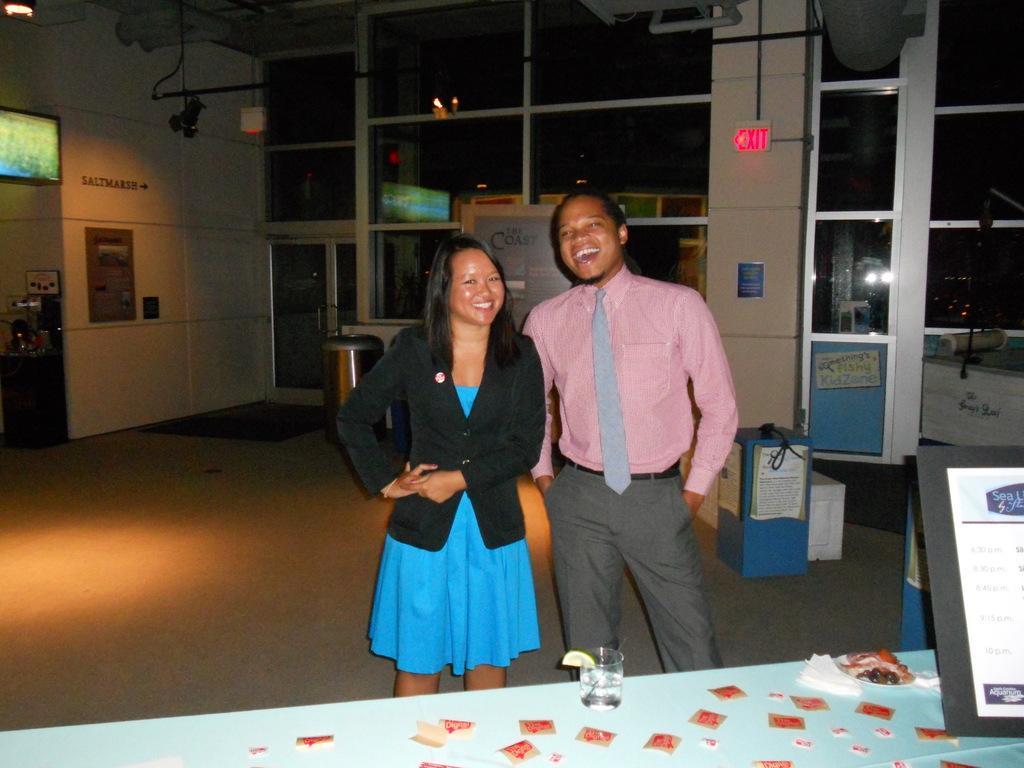How many people are present in the image? There is a woman and a man present in the image. What are the woman and man doing in the image? Both the woman and man are at a table. What objects can be seen on the table? There is a glass and a frame on the table. What can be seen in the background of the image? There are doors, a TV, boxes, another door, and a dustbin in the background of the image. What type of tomatoes can be seen growing in the image? There are no tomatoes present in the image; it features a woman and a man at a table with a glass and a frame, along with various objects in the background. 